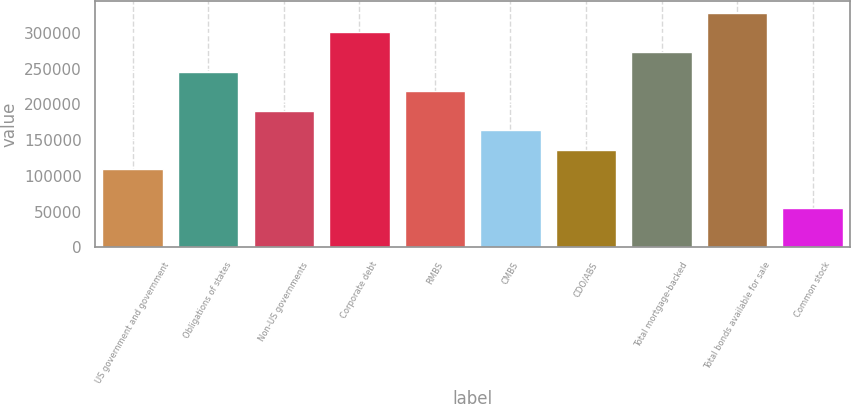<chart> <loc_0><loc_0><loc_500><loc_500><bar_chart><fcel>US government and government<fcel>Obligations of states<fcel>Non-US governments<fcel>Corporate debt<fcel>RMBS<fcel>CMBS<fcel>CDO/ABS<fcel>Total mortgage-backed<fcel>Total bonds available for sale<fcel>Common stock<nl><fcel>109315<fcel>245862<fcel>191243<fcel>300480<fcel>218552<fcel>163934<fcel>136624<fcel>273171<fcel>327790<fcel>54696.6<nl></chart> 